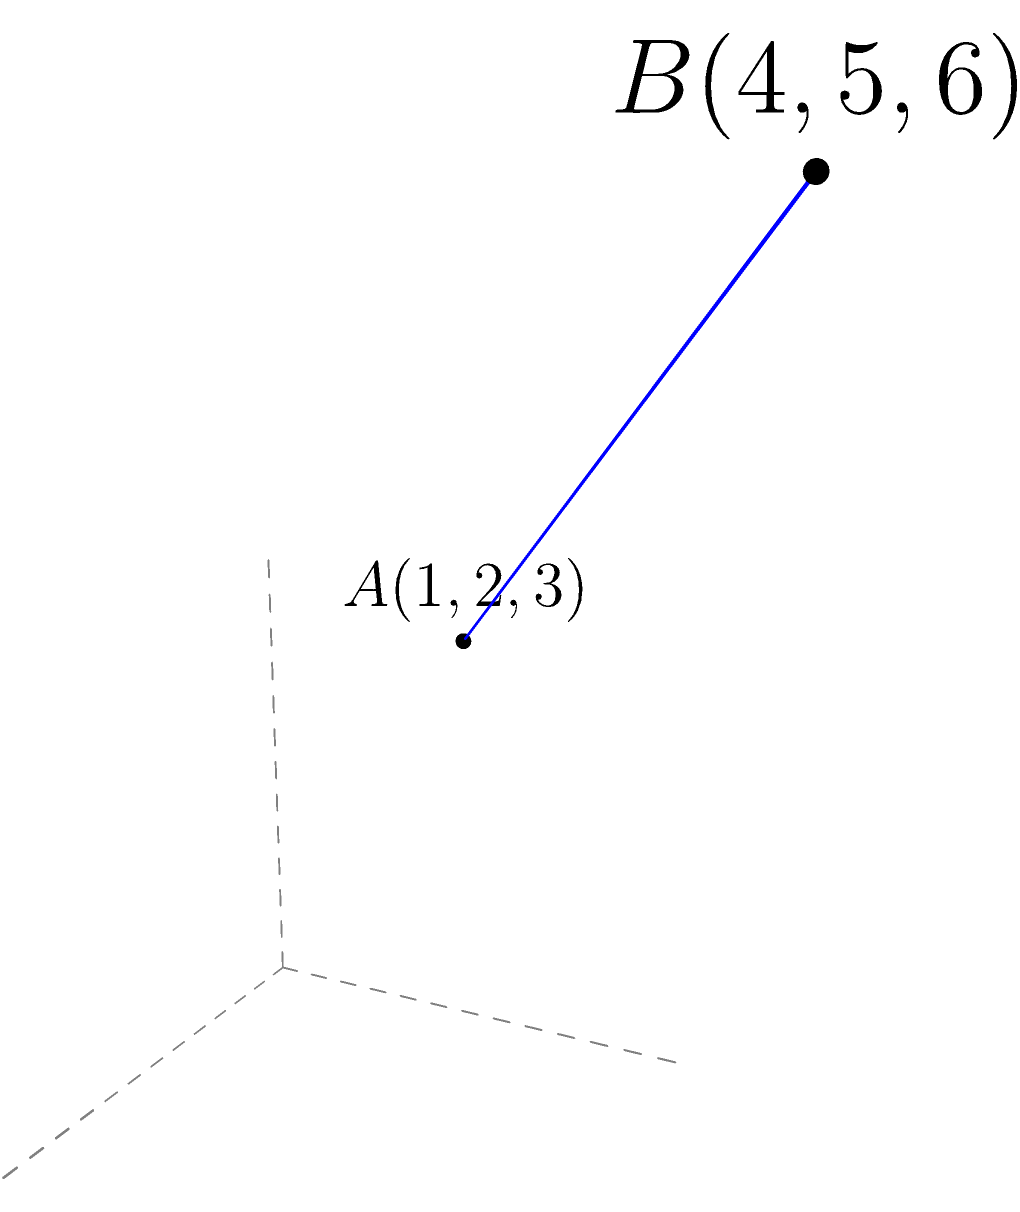In our cutting-edge 3D modeling software, we need to calculate the distance between two points in a 3D coordinate system. Given point $A(1,2,3)$ and point $B(4,5,6)$, what is the distance between these two points? Round your answer to two decimal places. To find the distance between two points in a 3D coordinate system, we use the 3D distance formula:

$$d = \sqrt{(x_2-x_1)^2 + (y_2-y_1)^2 + (z_2-z_1)^2}$$

Where $(x_1,y_1,z_1)$ are the coordinates of the first point and $(x_2,y_2,z_2)$ are the coordinates of the second point.

Step 1: Identify the coordinates
Point A: $(x_1,y_1,z_1) = (1,2,3)$
Point B: $(x_2,y_2,z_2) = (4,5,6)$

Step 2: Substitute the values into the formula
$$d = \sqrt{(4-1)^2 + (5-2)^2 + (6-3)^2}$$

Step 3: Simplify inside the parentheses
$$d = \sqrt{3^2 + 3^2 + 3^2}$$

Step 4: Calculate the squares
$$d = \sqrt{9 + 9 + 9}$$

Step 5: Add the values under the square root
$$d = \sqrt{27}$$

Step 6: Calculate the square root and round to two decimal places
$$d \approx 5.20$$

Therefore, the distance between points A and B is approximately 5.20 units.
Answer: 5.20 units 